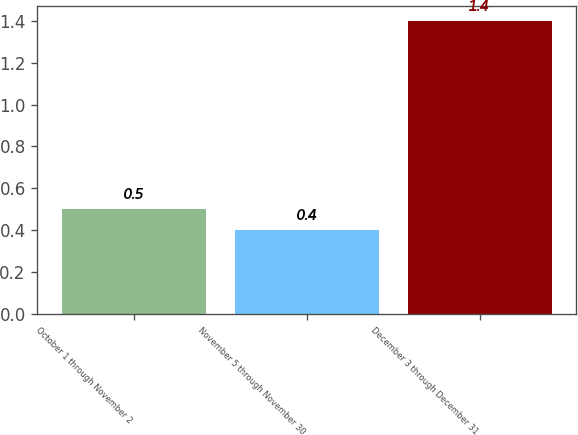Convert chart to OTSL. <chart><loc_0><loc_0><loc_500><loc_500><bar_chart><fcel>October 1 through November 2<fcel>November 5 through November 30<fcel>December 3 through December 31<nl><fcel>0.5<fcel>0.4<fcel>1.4<nl></chart> 